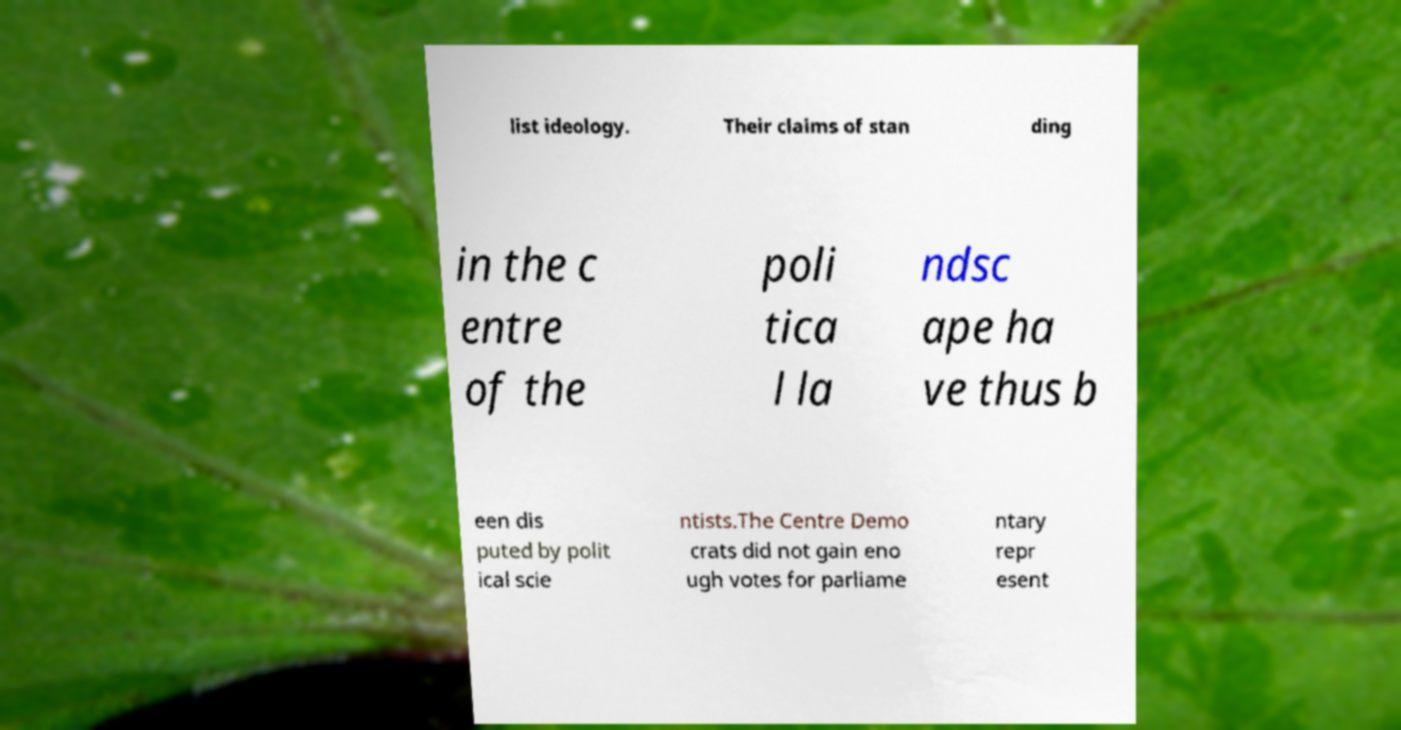What messages or text are displayed in this image? I need them in a readable, typed format. list ideology. Their claims of stan ding in the c entre of the poli tica l la ndsc ape ha ve thus b een dis puted by polit ical scie ntists.The Centre Demo crats did not gain eno ugh votes for parliame ntary repr esent 